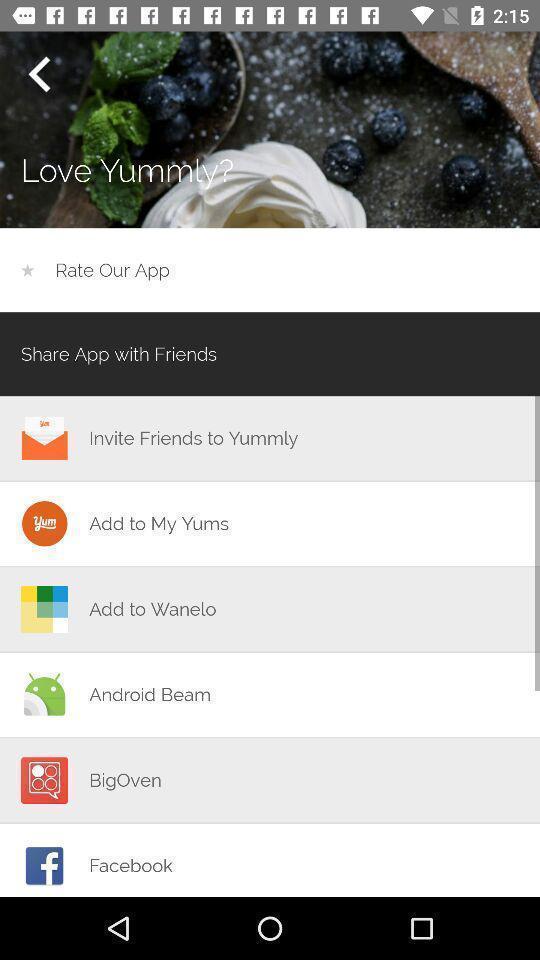Describe the content in this image. Pop up of sharing data with different social media. 